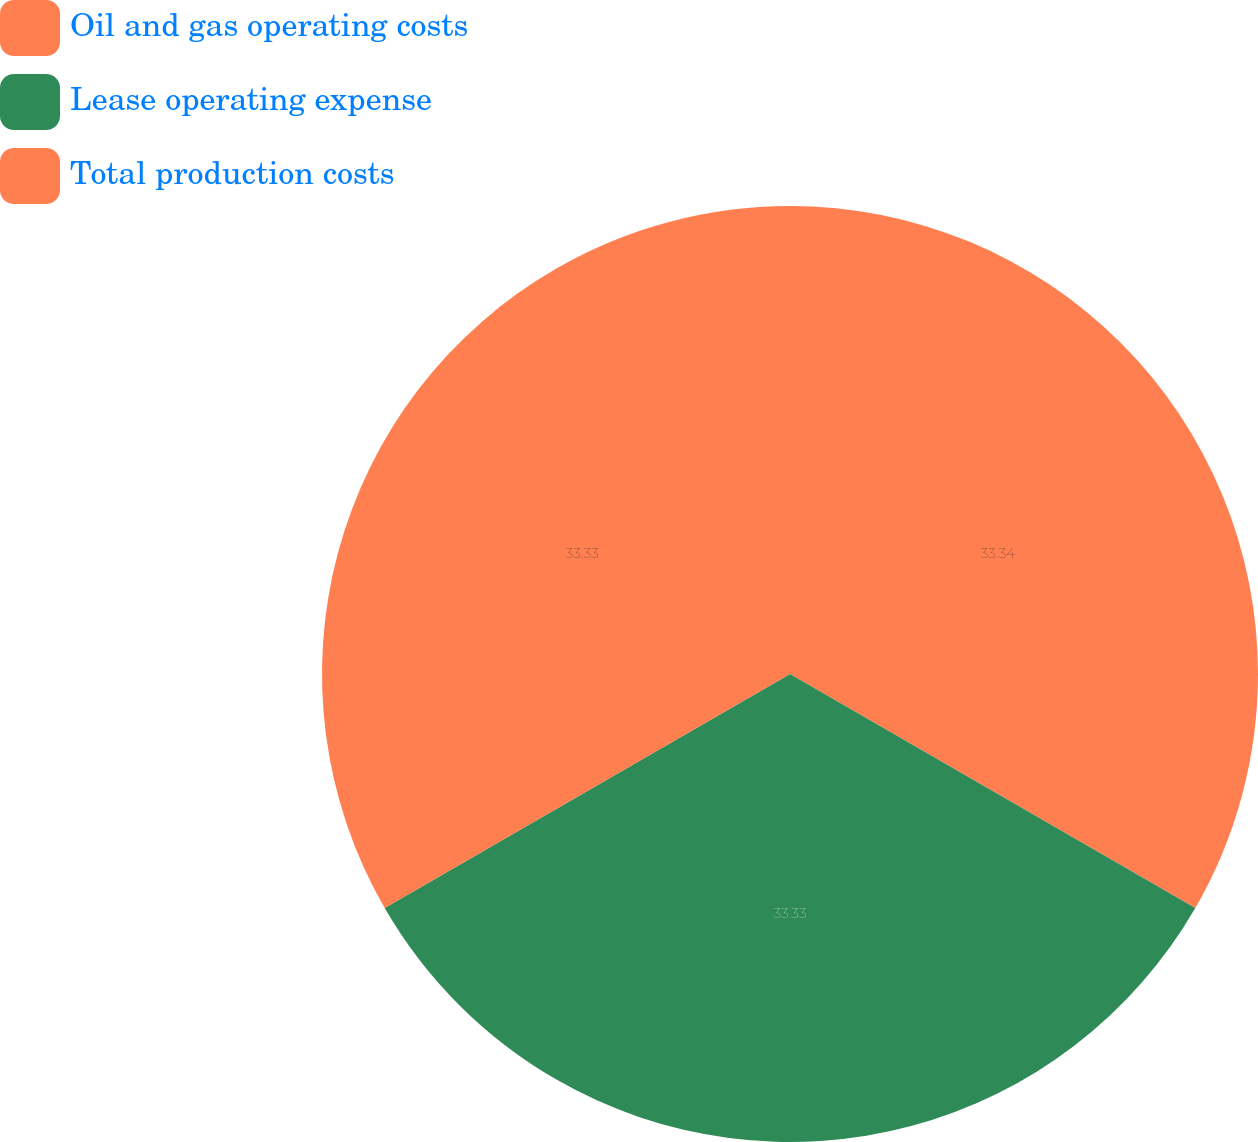Convert chart to OTSL. <chart><loc_0><loc_0><loc_500><loc_500><pie_chart><fcel>Oil and gas operating costs<fcel>Lease operating expense<fcel>Total production costs<nl><fcel>33.33%<fcel>33.33%<fcel>33.33%<nl></chart> 